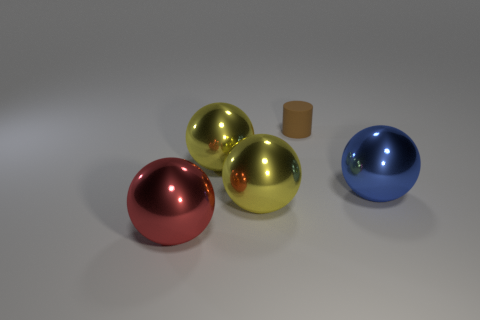Is there anything else that has the same size as the brown cylinder?
Your answer should be very brief. No. How many other things are the same shape as the blue metal thing?
Ensure brevity in your answer.  3. How many objects are big yellow things or balls that are on the right side of the brown cylinder?
Keep it short and to the point. 3. Is the number of brown rubber cylinders in front of the blue sphere greater than the number of small objects right of the tiny brown matte thing?
Make the answer very short. No. There is a big yellow metal object to the right of the yellow metal sphere behind the big ball to the right of the small brown rubber thing; what shape is it?
Offer a very short reply. Sphere. What is the shape of the yellow metal object in front of the large object that is to the right of the cylinder?
Offer a very short reply. Sphere. Is there a cylinder that has the same material as the red ball?
Keep it short and to the point. No. How many red things are big shiny balls or small cylinders?
Provide a succinct answer. 1. Are there any spheres of the same color as the matte object?
Offer a very short reply. No. The red object that is the same material as the blue ball is what size?
Keep it short and to the point. Large. 